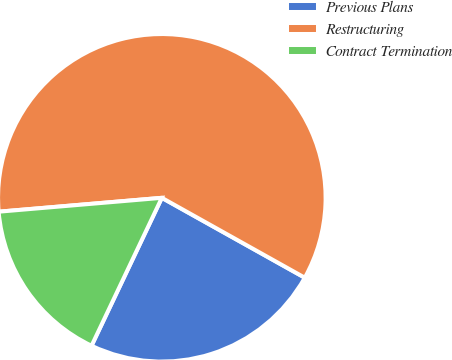<chart> <loc_0><loc_0><loc_500><loc_500><pie_chart><fcel>Previous Plans<fcel>Restructuring<fcel>Contract Termination<nl><fcel>23.95%<fcel>59.46%<fcel>16.59%<nl></chart> 